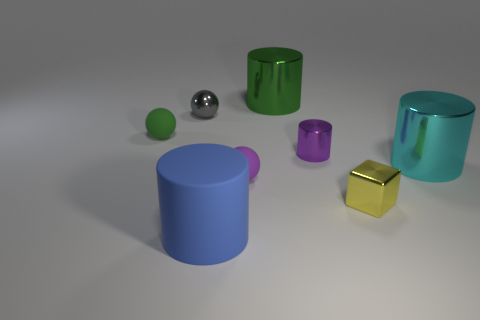Subtract 1 spheres. How many spheres are left? 2 Subtract all blue cylinders. How many cylinders are left? 3 Subtract all cyan cylinders. How many cylinders are left? 3 Add 1 large purple shiny blocks. How many objects exist? 9 Subtract all red cylinders. Subtract all cyan cubes. How many cylinders are left? 4 Subtract all spheres. How many objects are left? 5 Add 5 tiny shiny cylinders. How many tiny shiny cylinders are left? 6 Add 7 small purple metallic cylinders. How many small purple metallic cylinders exist? 8 Subtract 1 blue cylinders. How many objects are left? 7 Subtract all large shiny objects. Subtract all gray metallic spheres. How many objects are left? 5 